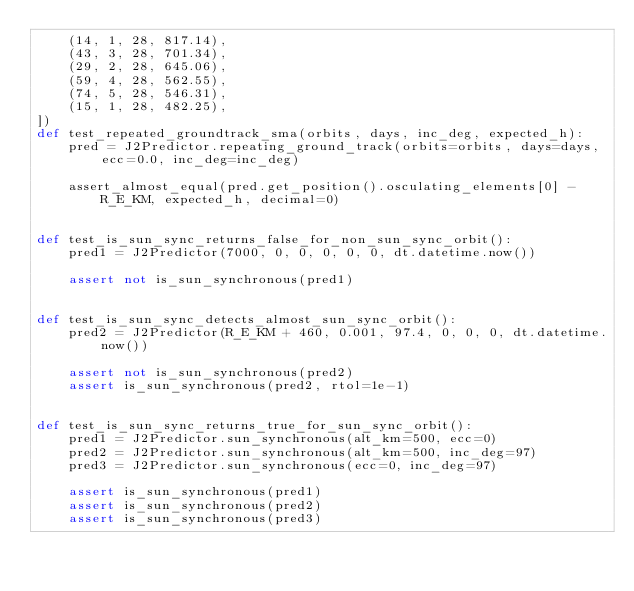Convert code to text. <code><loc_0><loc_0><loc_500><loc_500><_Python_>    (14, 1, 28, 817.14),
    (43, 3, 28, 701.34),
    (29, 2, 28, 645.06),
    (59, 4, 28, 562.55),
    (74, 5, 28, 546.31),
    (15, 1, 28, 482.25),
])
def test_repeated_groundtrack_sma(orbits, days, inc_deg, expected_h):
    pred = J2Predictor.repeating_ground_track(orbits=orbits, days=days, ecc=0.0, inc_deg=inc_deg)

    assert_almost_equal(pred.get_position().osculating_elements[0] - R_E_KM, expected_h, decimal=0)


def test_is_sun_sync_returns_false_for_non_sun_sync_orbit():
    pred1 = J2Predictor(7000, 0, 0, 0, 0, 0, dt.datetime.now())

    assert not is_sun_synchronous(pred1)


def test_is_sun_sync_detects_almost_sun_sync_orbit():
    pred2 = J2Predictor(R_E_KM + 460, 0.001, 97.4, 0, 0, 0, dt.datetime.now())

    assert not is_sun_synchronous(pred2)
    assert is_sun_synchronous(pred2, rtol=1e-1)


def test_is_sun_sync_returns_true_for_sun_sync_orbit():
    pred1 = J2Predictor.sun_synchronous(alt_km=500, ecc=0)
    pred2 = J2Predictor.sun_synchronous(alt_km=500, inc_deg=97)
    pred3 = J2Predictor.sun_synchronous(ecc=0, inc_deg=97)

    assert is_sun_synchronous(pred1)
    assert is_sun_synchronous(pred2)
    assert is_sun_synchronous(pred3)
</code> 